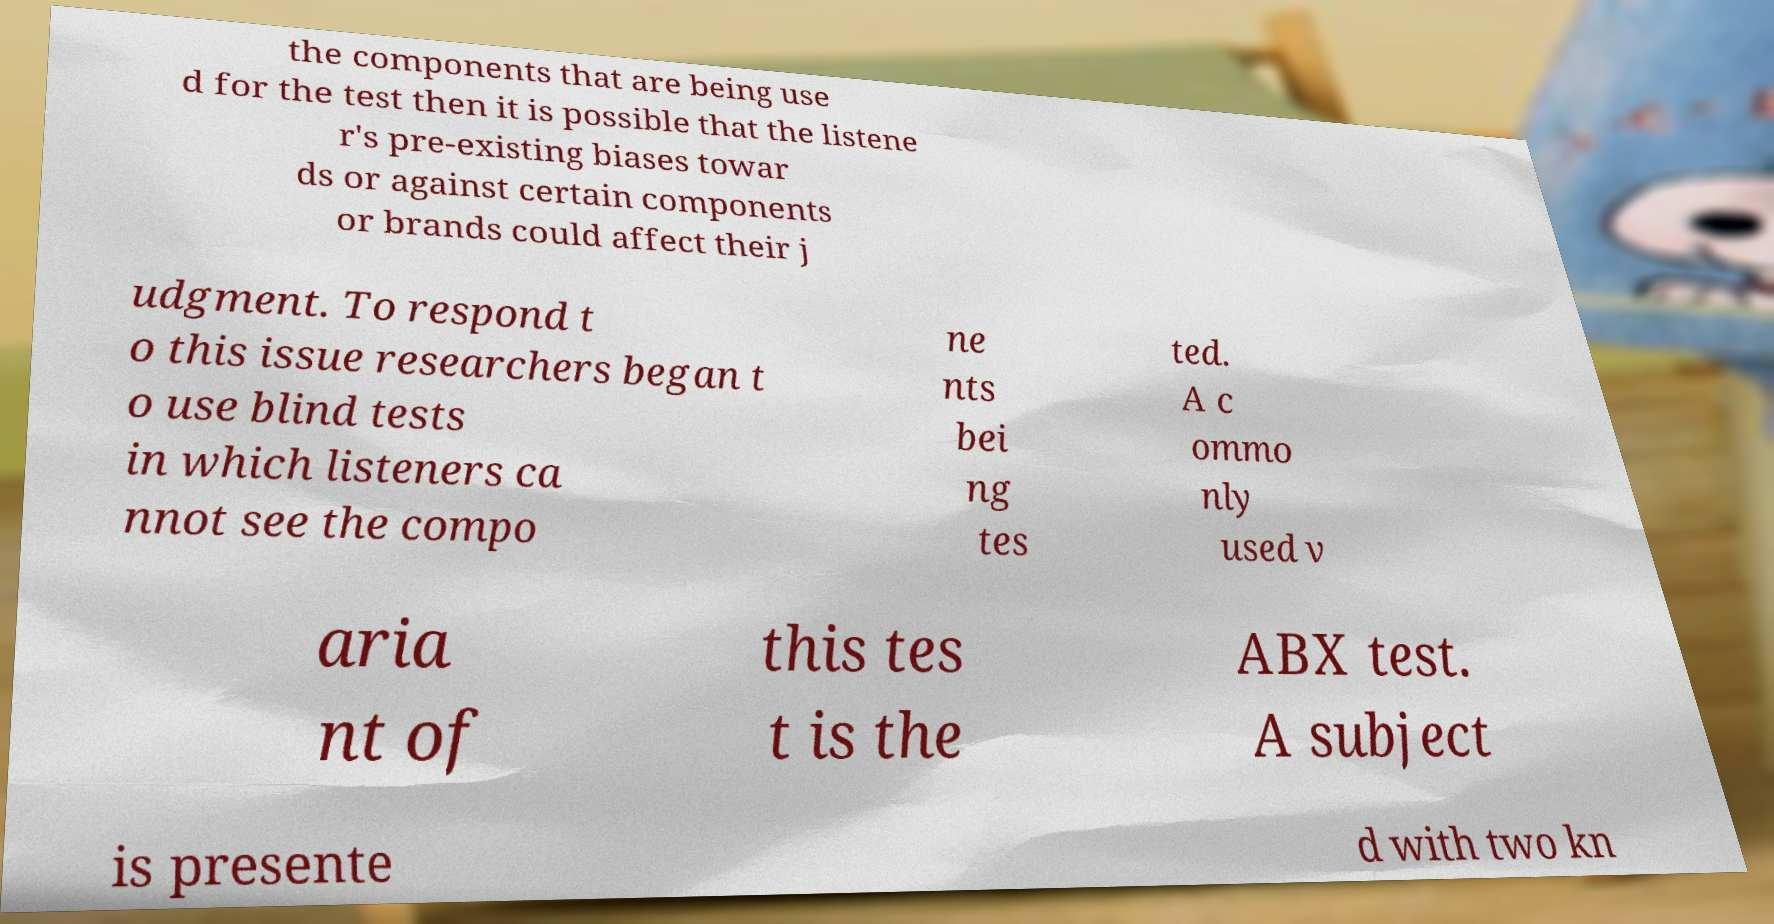Could you assist in decoding the text presented in this image and type it out clearly? the components that are being use d for the test then it is possible that the listene r's pre-existing biases towar ds or against certain components or brands could affect their j udgment. To respond t o this issue researchers began t o use blind tests in which listeners ca nnot see the compo ne nts bei ng tes ted. A c ommo nly used v aria nt of this tes t is the ABX test. A subject is presente d with two kn 